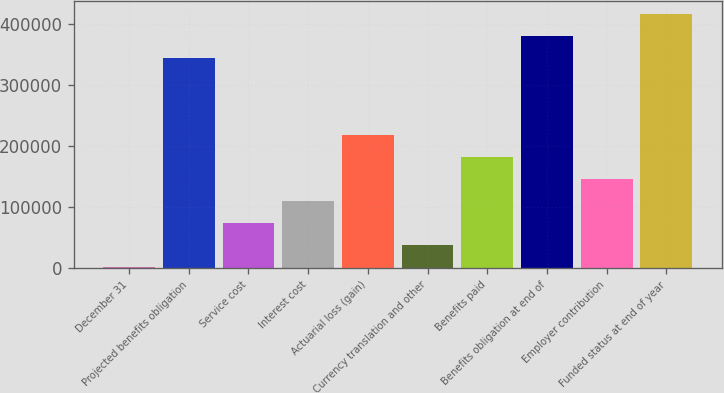Convert chart to OTSL. <chart><loc_0><loc_0><loc_500><loc_500><bar_chart><fcel>December 31<fcel>Projected benefits obligation<fcel>Service cost<fcel>Interest cost<fcel>Actuarial loss (gain)<fcel>Currency translation and other<fcel>Benefits paid<fcel>Benefits obligation at end of<fcel>Employer contribution<fcel>Funded status at end of year<nl><fcel>2007<fcel>345116<fcel>74188.8<fcel>110280<fcel>218552<fcel>38097.9<fcel>182462<fcel>381207<fcel>146371<fcel>417298<nl></chart> 